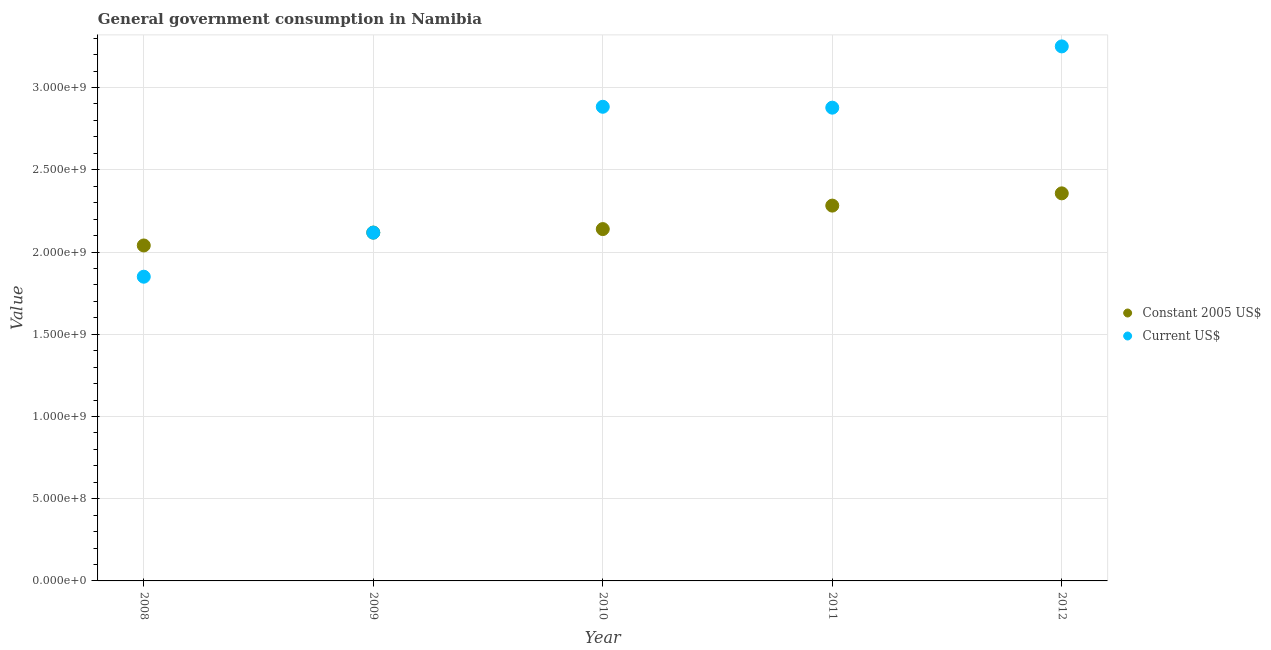Is the number of dotlines equal to the number of legend labels?
Provide a short and direct response. Yes. What is the value consumed in constant 2005 us$ in 2009?
Your response must be concise. 2.12e+09. Across all years, what is the maximum value consumed in current us$?
Make the answer very short. 3.25e+09. Across all years, what is the minimum value consumed in current us$?
Give a very brief answer. 1.85e+09. What is the total value consumed in constant 2005 us$ in the graph?
Provide a short and direct response. 1.09e+1. What is the difference between the value consumed in current us$ in 2008 and that in 2010?
Your answer should be compact. -1.03e+09. What is the difference between the value consumed in current us$ in 2011 and the value consumed in constant 2005 us$ in 2010?
Provide a short and direct response. 7.38e+08. What is the average value consumed in constant 2005 us$ per year?
Offer a very short reply. 2.19e+09. In the year 2008, what is the difference between the value consumed in constant 2005 us$ and value consumed in current us$?
Offer a terse response. 1.90e+08. What is the ratio of the value consumed in constant 2005 us$ in 2009 to that in 2012?
Provide a succinct answer. 0.9. What is the difference between the highest and the second highest value consumed in constant 2005 us$?
Provide a succinct answer. 7.45e+07. What is the difference between the highest and the lowest value consumed in current us$?
Keep it short and to the point. 1.40e+09. Is the sum of the value consumed in current us$ in 2011 and 2012 greater than the maximum value consumed in constant 2005 us$ across all years?
Your answer should be very brief. Yes. Is the value consumed in constant 2005 us$ strictly greater than the value consumed in current us$ over the years?
Provide a short and direct response. No. How many dotlines are there?
Keep it short and to the point. 2. What is the difference between two consecutive major ticks on the Y-axis?
Keep it short and to the point. 5.00e+08. Are the values on the major ticks of Y-axis written in scientific E-notation?
Provide a short and direct response. Yes. How many legend labels are there?
Make the answer very short. 2. What is the title of the graph?
Your answer should be very brief. General government consumption in Namibia. What is the label or title of the X-axis?
Offer a very short reply. Year. What is the label or title of the Y-axis?
Provide a succinct answer. Value. What is the Value in Constant 2005 US$ in 2008?
Ensure brevity in your answer.  2.04e+09. What is the Value of Current US$ in 2008?
Ensure brevity in your answer.  1.85e+09. What is the Value in Constant 2005 US$ in 2009?
Provide a succinct answer. 2.12e+09. What is the Value of Current US$ in 2009?
Provide a succinct answer. 2.12e+09. What is the Value of Constant 2005 US$ in 2010?
Offer a very short reply. 2.14e+09. What is the Value in Current US$ in 2010?
Your answer should be very brief. 2.88e+09. What is the Value of Constant 2005 US$ in 2011?
Offer a very short reply. 2.28e+09. What is the Value in Current US$ in 2011?
Make the answer very short. 2.88e+09. What is the Value of Constant 2005 US$ in 2012?
Your answer should be very brief. 2.36e+09. What is the Value of Current US$ in 2012?
Make the answer very short. 3.25e+09. Across all years, what is the maximum Value in Constant 2005 US$?
Provide a succinct answer. 2.36e+09. Across all years, what is the maximum Value of Current US$?
Your response must be concise. 3.25e+09. Across all years, what is the minimum Value in Constant 2005 US$?
Your answer should be very brief. 2.04e+09. Across all years, what is the minimum Value of Current US$?
Make the answer very short. 1.85e+09. What is the total Value of Constant 2005 US$ in the graph?
Make the answer very short. 1.09e+1. What is the total Value in Current US$ in the graph?
Make the answer very short. 1.30e+1. What is the difference between the Value of Constant 2005 US$ in 2008 and that in 2009?
Keep it short and to the point. -7.83e+07. What is the difference between the Value of Current US$ in 2008 and that in 2009?
Make the answer very short. -2.68e+08. What is the difference between the Value of Constant 2005 US$ in 2008 and that in 2010?
Your answer should be compact. -9.97e+07. What is the difference between the Value in Current US$ in 2008 and that in 2010?
Provide a short and direct response. -1.03e+09. What is the difference between the Value of Constant 2005 US$ in 2008 and that in 2011?
Offer a very short reply. -2.42e+08. What is the difference between the Value in Current US$ in 2008 and that in 2011?
Make the answer very short. -1.03e+09. What is the difference between the Value in Constant 2005 US$ in 2008 and that in 2012?
Give a very brief answer. -3.17e+08. What is the difference between the Value of Current US$ in 2008 and that in 2012?
Provide a succinct answer. -1.40e+09. What is the difference between the Value in Constant 2005 US$ in 2009 and that in 2010?
Offer a very short reply. -2.13e+07. What is the difference between the Value in Current US$ in 2009 and that in 2010?
Offer a very short reply. -7.65e+08. What is the difference between the Value in Constant 2005 US$ in 2009 and that in 2011?
Offer a terse response. -1.64e+08. What is the difference between the Value of Current US$ in 2009 and that in 2011?
Your answer should be compact. -7.60e+08. What is the difference between the Value in Constant 2005 US$ in 2009 and that in 2012?
Give a very brief answer. -2.39e+08. What is the difference between the Value in Current US$ in 2009 and that in 2012?
Your answer should be very brief. -1.13e+09. What is the difference between the Value in Constant 2005 US$ in 2010 and that in 2011?
Ensure brevity in your answer.  -1.43e+08. What is the difference between the Value in Current US$ in 2010 and that in 2011?
Give a very brief answer. 5.40e+06. What is the difference between the Value in Constant 2005 US$ in 2010 and that in 2012?
Make the answer very short. -2.17e+08. What is the difference between the Value of Current US$ in 2010 and that in 2012?
Your answer should be very brief. -3.67e+08. What is the difference between the Value in Constant 2005 US$ in 2011 and that in 2012?
Your response must be concise. -7.45e+07. What is the difference between the Value in Current US$ in 2011 and that in 2012?
Give a very brief answer. -3.73e+08. What is the difference between the Value in Constant 2005 US$ in 2008 and the Value in Current US$ in 2009?
Make the answer very short. -7.80e+07. What is the difference between the Value of Constant 2005 US$ in 2008 and the Value of Current US$ in 2010?
Give a very brief answer. -8.43e+08. What is the difference between the Value in Constant 2005 US$ in 2008 and the Value in Current US$ in 2011?
Provide a short and direct response. -8.38e+08. What is the difference between the Value of Constant 2005 US$ in 2008 and the Value of Current US$ in 2012?
Your answer should be compact. -1.21e+09. What is the difference between the Value of Constant 2005 US$ in 2009 and the Value of Current US$ in 2010?
Your response must be concise. -7.65e+08. What is the difference between the Value of Constant 2005 US$ in 2009 and the Value of Current US$ in 2011?
Keep it short and to the point. -7.60e+08. What is the difference between the Value in Constant 2005 US$ in 2009 and the Value in Current US$ in 2012?
Ensure brevity in your answer.  -1.13e+09. What is the difference between the Value of Constant 2005 US$ in 2010 and the Value of Current US$ in 2011?
Offer a very short reply. -7.38e+08. What is the difference between the Value in Constant 2005 US$ in 2010 and the Value in Current US$ in 2012?
Provide a succinct answer. -1.11e+09. What is the difference between the Value of Constant 2005 US$ in 2011 and the Value of Current US$ in 2012?
Offer a very short reply. -9.68e+08. What is the average Value of Constant 2005 US$ per year?
Make the answer very short. 2.19e+09. What is the average Value of Current US$ per year?
Make the answer very short. 2.60e+09. In the year 2008, what is the difference between the Value of Constant 2005 US$ and Value of Current US$?
Your answer should be very brief. 1.90e+08. In the year 2009, what is the difference between the Value in Constant 2005 US$ and Value in Current US$?
Your answer should be very brief. 3.34e+05. In the year 2010, what is the difference between the Value of Constant 2005 US$ and Value of Current US$?
Your answer should be very brief. -7.44e+08. In the year 2011, what is the difference between the Value of Constant 2005 US$ and Value of Current US$?
Ensure brevity in your answer.  -5.96e+08. In the year 2012, what is the difference between the Value of Constant 2005 US$ and Value of Current US$?
Your response must be concise. -8.94e+08. What is the ratio of the Value of Constant 2005 US$ in 2008 to that in 2009?
Your answer should be compact. 0.96. What is the ratio of the Value in Current US$ in 2008 to that in 2009?
Give a very brief answer. 0.87. What is the ratio of the Value in Constant 2005 US$ in 2008 to that in 2010?
Keep it short and to the point. 0.95. What is the ratio of the Value in Current US$ in 2008 to that in 2010?
Provide a short and direct response. 0.64. What is the ratio of the Value of Constant 2005 US$ in 2008 to that in 2011?
Ensure brevity in your answer.  0.89. What is the ratio of the Value of Current US$ in 2008 to that in 2011?
Your answer should be very brief. 0.64. What is the ratio of the Value in Constant 2005 US$ in 2008 to that in 2012?
Your answer should be very brief. 0.87. What is the ratio of the Value in Current US$ in 2008 to that in 2012?
Make the answer very short. 0.57. What is the ratio of the Value of Current US$ in 2009 to that in 2010?
Provide a short and direct response. 0.73. What is the ratio of the Value in Constant 2005 US$ in 2009 to that in 2011?
Provide a succinct answer. 0.93. What is the ratio of the Value in Current US$ in 2009 to that in 2011?
Your answer should be very brief. 0.74. What is the ratio of the Value of Constant 2005 US$ in 2009 to that in 2012?
Your response must be concise. 0.9. What is the ratio of the Value of Current US$ in 2009 to that in 2012?
Offer a terse response. 0.65. What is the ratio of the Value in Constant 2005 US$ in 2010 to that in 2011?
Your answer should be compact. 0.94. What is the ratio of the Value in Current US$ in 2010 to that in 2011?
Ensure brevity in your answer.  1. What is the ratio of the Value of Constant 2005 US$ in 2010 to that in 2012?
Your response must be concise. 0.91. What is the ratio of the Value of Current US$ in 2010 to that in 2012?
Make the answer very short. 0.89. What is the ratio of the Value in Constant 2005 US$ in 2011 to that in 2012?
Give a very brief answer. 0.97. What is the ratio of the Value of Current US$ in 2011 to that in 2012?
Keep it short and to the point. 0.89. What is the difference between the highest and the second highest Value of Constant 2005 US$?
Ensure brevity in your answer.  7.45e+07. What is the difference between the highest and the second highest Value in Current US$?
Offer a terse response. 3.67e+08. What is the difference between the highest and the lowest Value of Constant 2005 US$?
Offer a terse response. 3.17e+08. What is the difference between the highest and the lowest Value in Current US$?
Provide a succinct answer. 1.40e+09. 